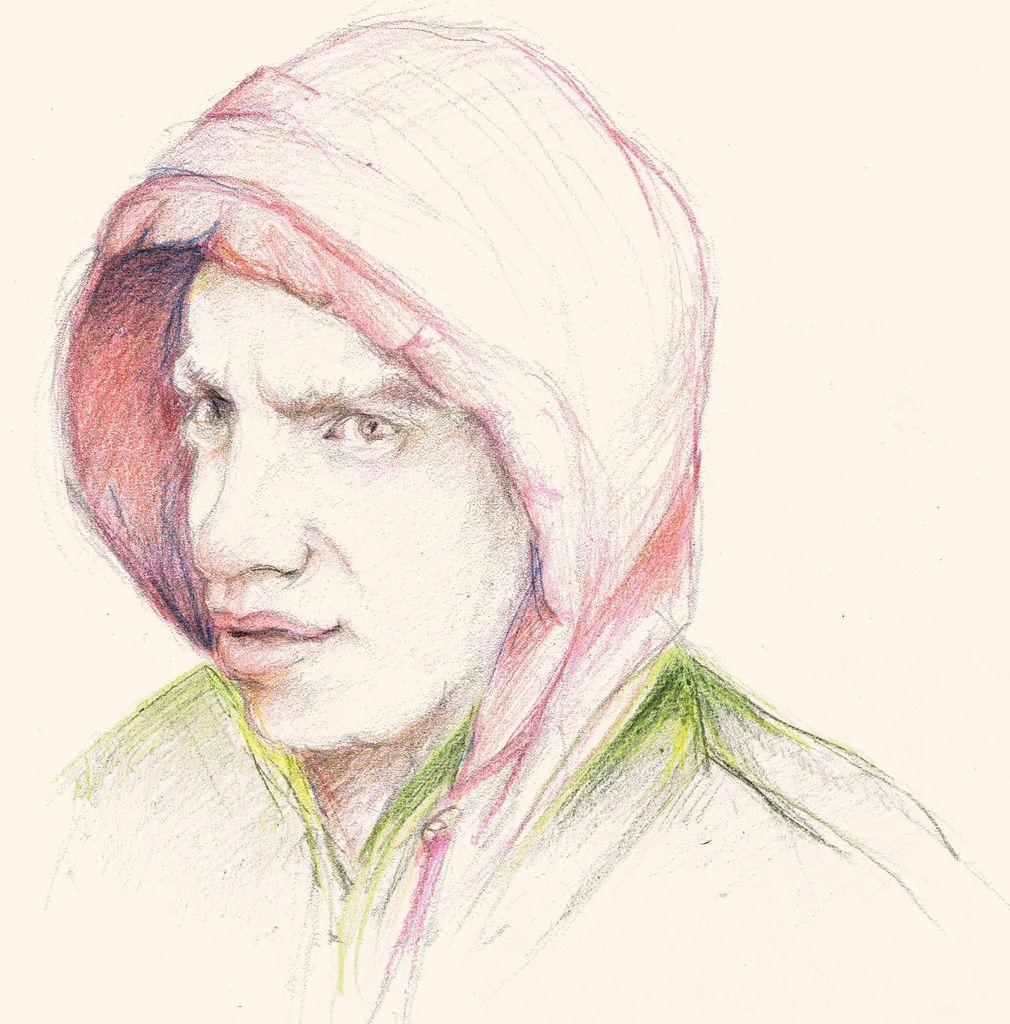In one or two sentences, can you explain what this image depicts? This image consists of a paper with a sketch of a man on it. 